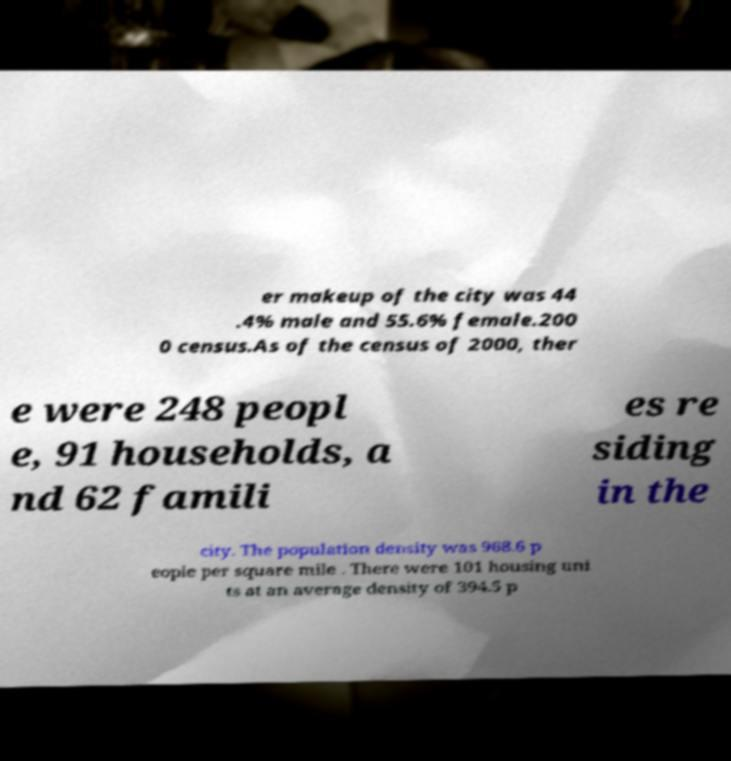Please identify and transcribe the text found in this image. er makeup of the city was 44 .4% male and 55.6% female.200 0 census.As of the census of 2000, ther e were 248 peopl e, 91 households, a nd 62 famili es re siding in the city. The population density was 968.6 p eople per square mile . There were 101 housing uni ts at an average density of 394.5 p 